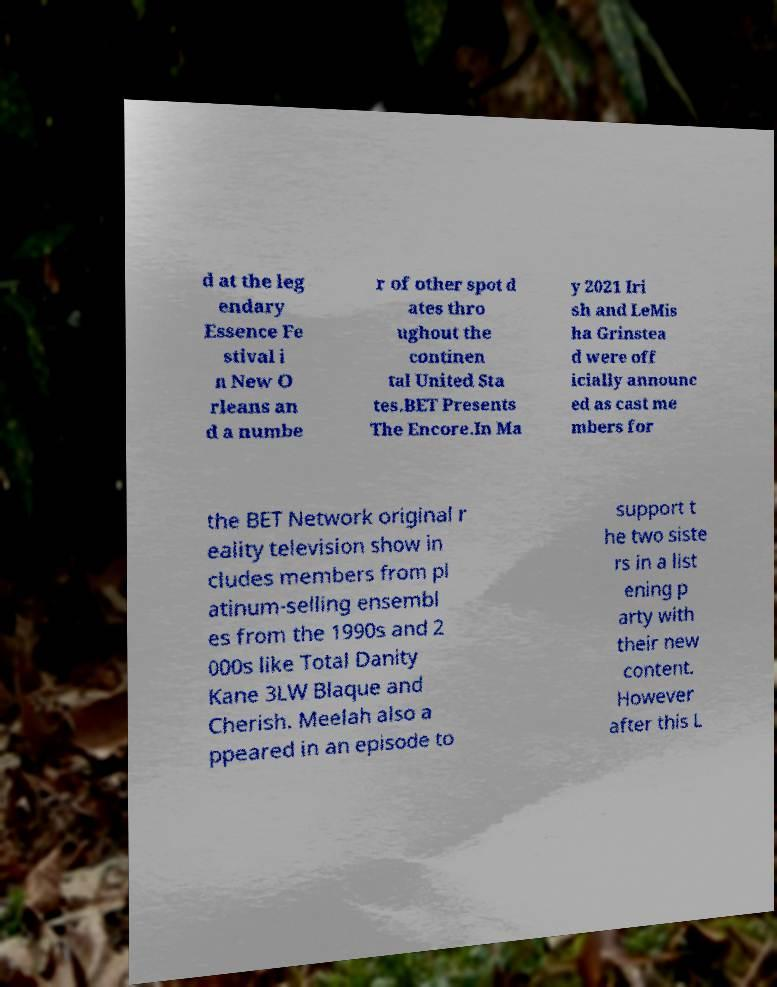Could you extract and type out the text from this image? d at the leg endary Essence Fe stival i n New O rleans an d a numbe r of other spot d ates thro ughout the continen tal United Sta tes.BET Presents The Encore.In Ma y 2021 Iri sh and LeMis ha Grinstea d were off icially announc ed as cast me mbers for the BET Network original r eality television show in cludes members from pl atinum-selling ensembl es from the 1990s and 2 000s like Total Danity Kane 3LW Blaque and Cherish. Meelah also a ppeared in an episode to support t he two siste rs in a list ening p arty with their new content. However after this L 